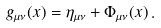Convert formula to latex. <formula><loc_0><loc_0><loc_500><loc_500>g _ { \mu \nu } ( x ) = \eta _ { \mu \nu } + \Phi _ { \mu \nu } ( x ) \, .</formula> 